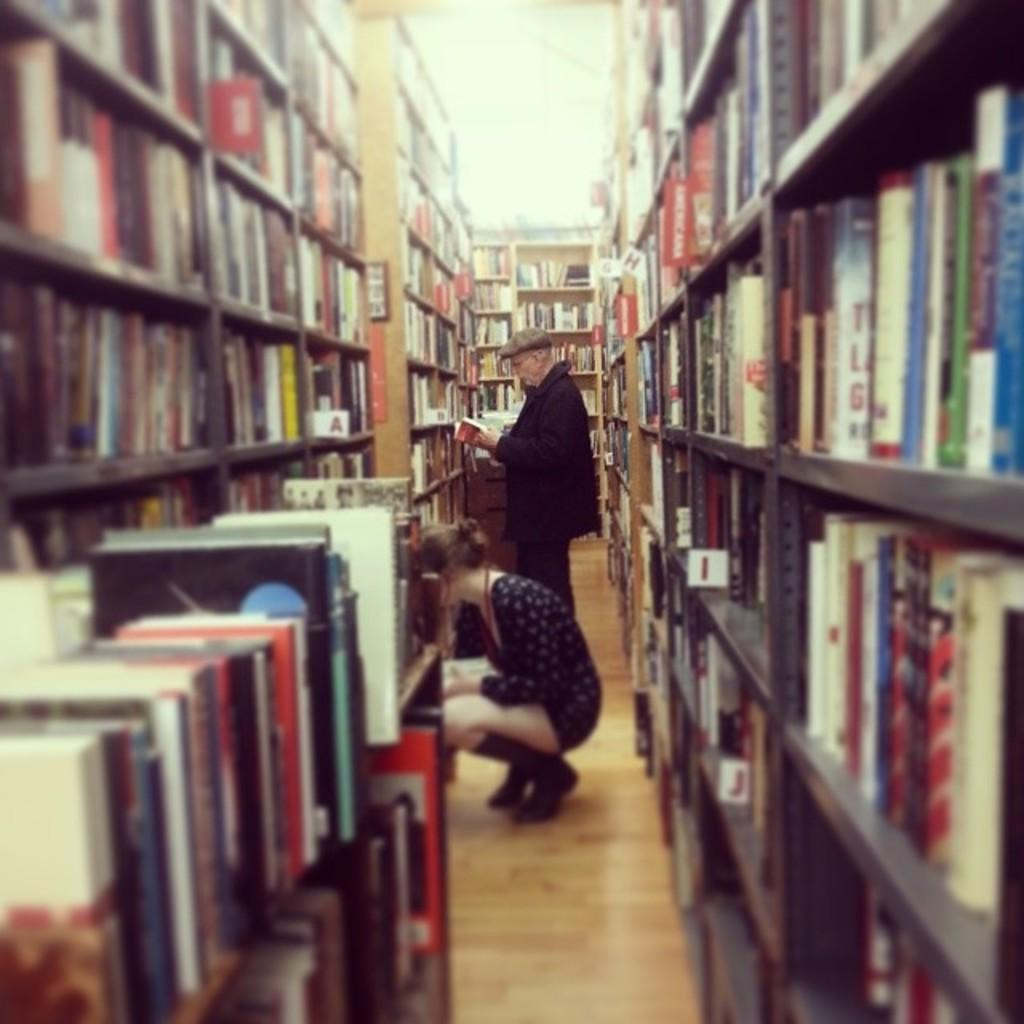<image>
Share a concise interpretation of the image provided. Two people are in a library aisle with one section near the top labeled Americana. 